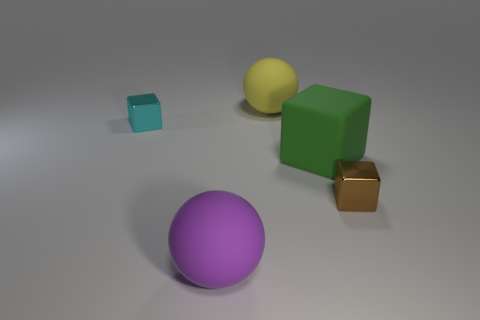Subtract all brown shiny cubes. How many cubes are left? 2 Add 2 large gray matte cubes. How many objects exist? 7 Subtract all balls. How many objects are left? 3 Subtract 0 blue cubes. How many objects are left? 5 Subtract all tiny cyan cubes. Subtract all yellow shiny cylinders. How many objects are left? 4 Add 5 green rubber cubes. How many green rubber cubes are left? 6 Add 4 big yellow matte balls. How many big yellow matte balls exist? 5 